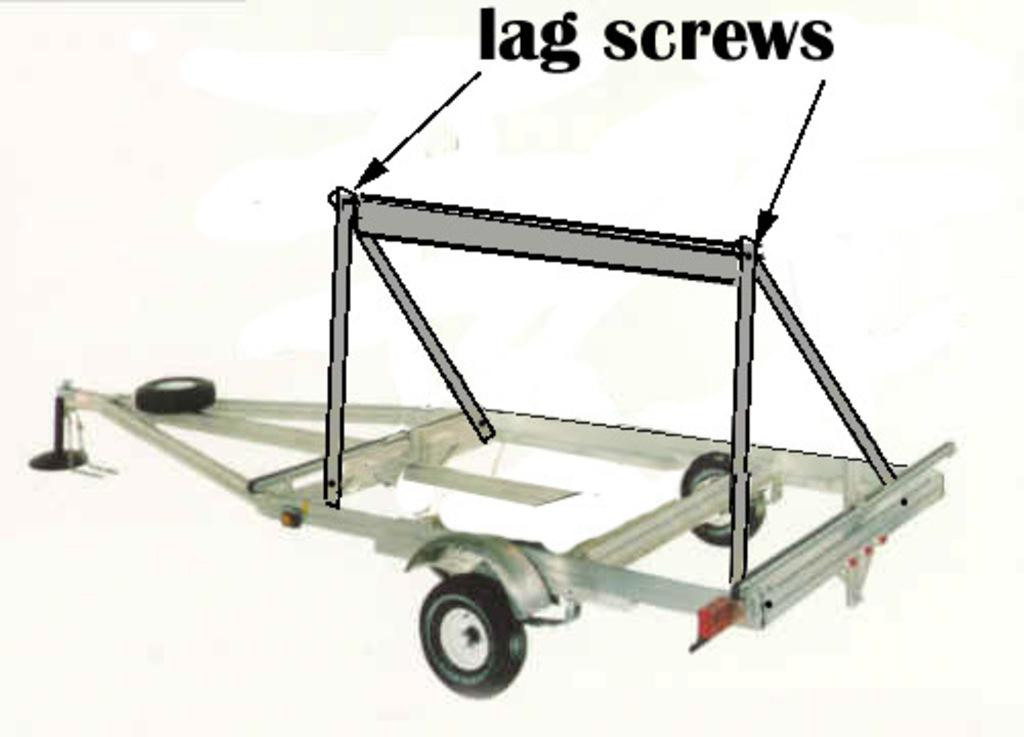What type of object with wheels can be seen in the image? There is an object with wheels in the image, but the specific type is not mentioned. What is the animated stand in the image? The animated stand in the image is labelled, but the specific label or content is not mentioned. What color is the background of the image? The background of the image is white. What language is spoken by the people sitting on the sofa in the image? There is no sofa or people present in the image. What type of camp can be seen in the background of the image? There is no camp present in the image; the background is white. 